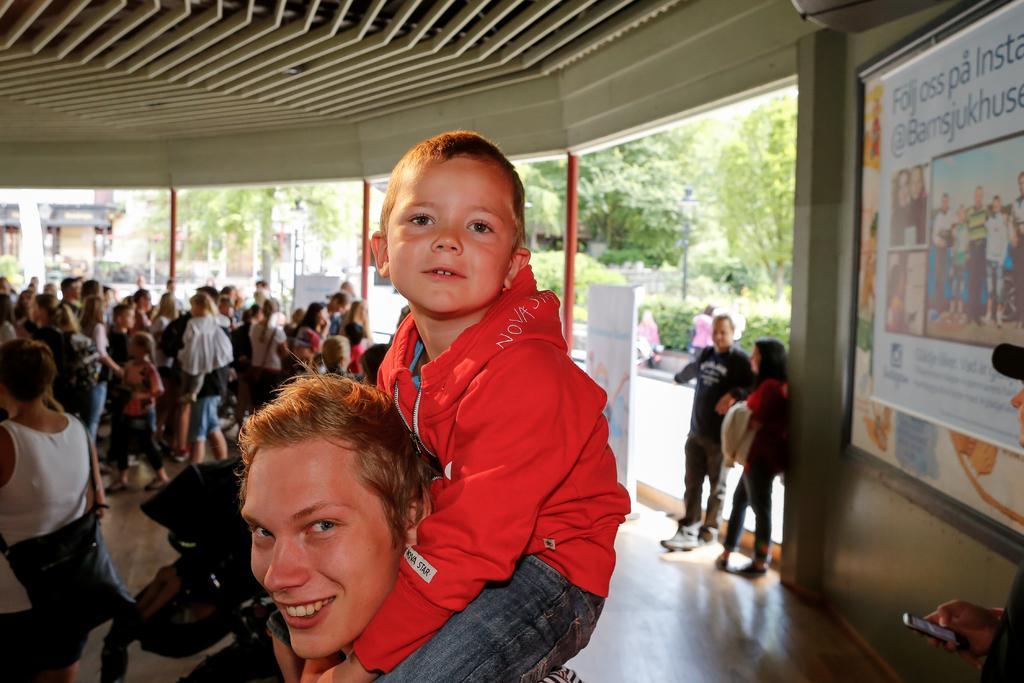In one or two sentences, can you explain what this image depicts? In this picture there is a person and there is a kid sitting on his shoulders and there are few other persons beside him and there is a banner in the right corner and there are trees and some other objects in the background. 